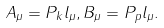<formula> <loc_0><loc_0><loc_500><loc_500>A _ { \mu } = P _ { k } l _ { \mu } , B _ { \mu } = P _ { p } l _ { \mu } .</formula> 